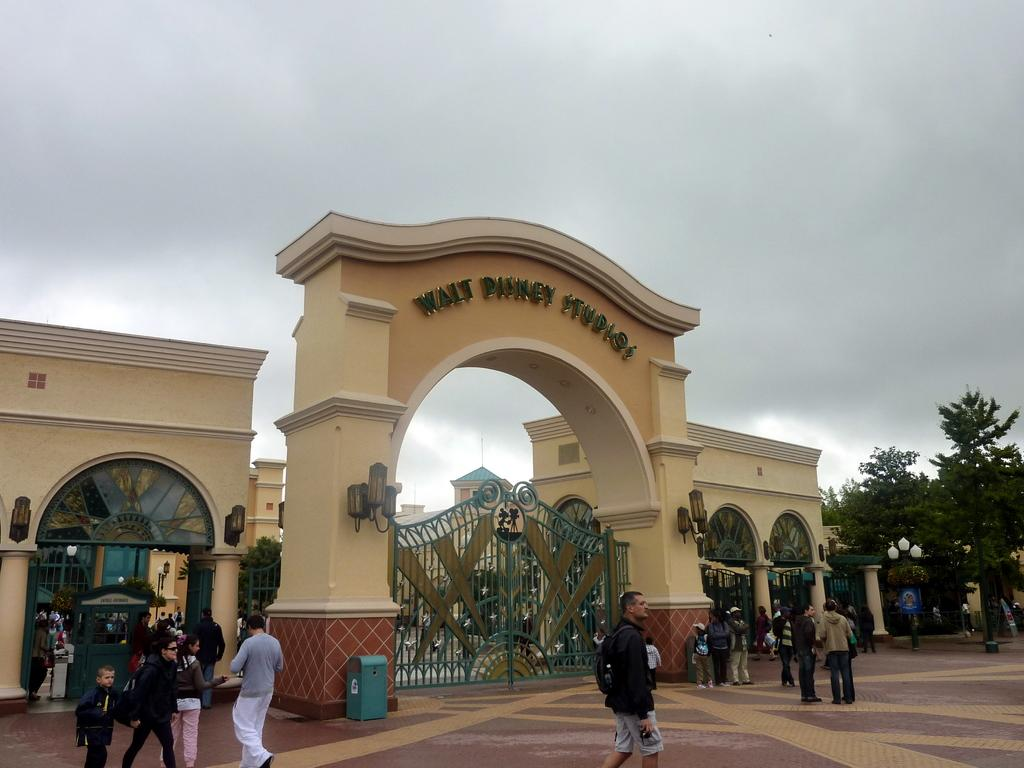<image>
Provide a brief description of the given image. An arch above a closed ironwork gate says, "Walt Disney Studios". 